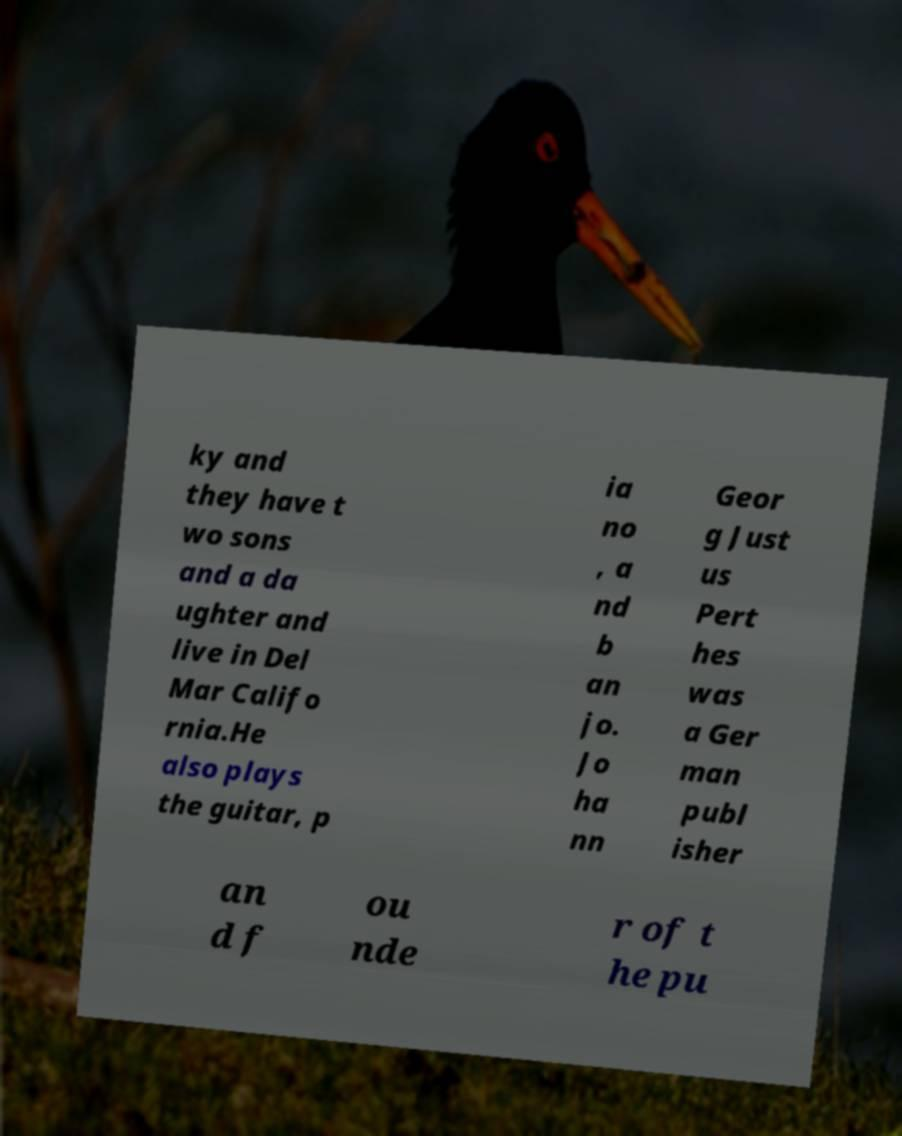Please read and relay the text visible in this image. What does it say? ky and they have t wo sons and a da ughter and live in Del Mar Califo rnia.He also plays the guitar, p ia no , a nd b an jo. Jo ha nn Geor g Just us Pert hes was a Ger man publ isher an d f ou nde r of t he pu 